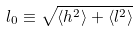Convert formula to latex. <formula><loc_0><loc_0><loc_500><loc_500>l _ { 0 } \equiv \sqrt { \langle h ^ { 2 } \rangle + \langle l ^ { 2 } \rangle }</formula> 